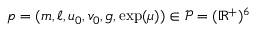Convert formula to latex. <formula><loc_0><loc_0><loc_500><loc_500>p = ( m , \ell , u _ { 0 } , v _ { 0 } , g , \exp ( \mu ) ) \in \mathcal { P } = ( \mathbb { R } ^ { + } ) ^ { 6 }</formula> 